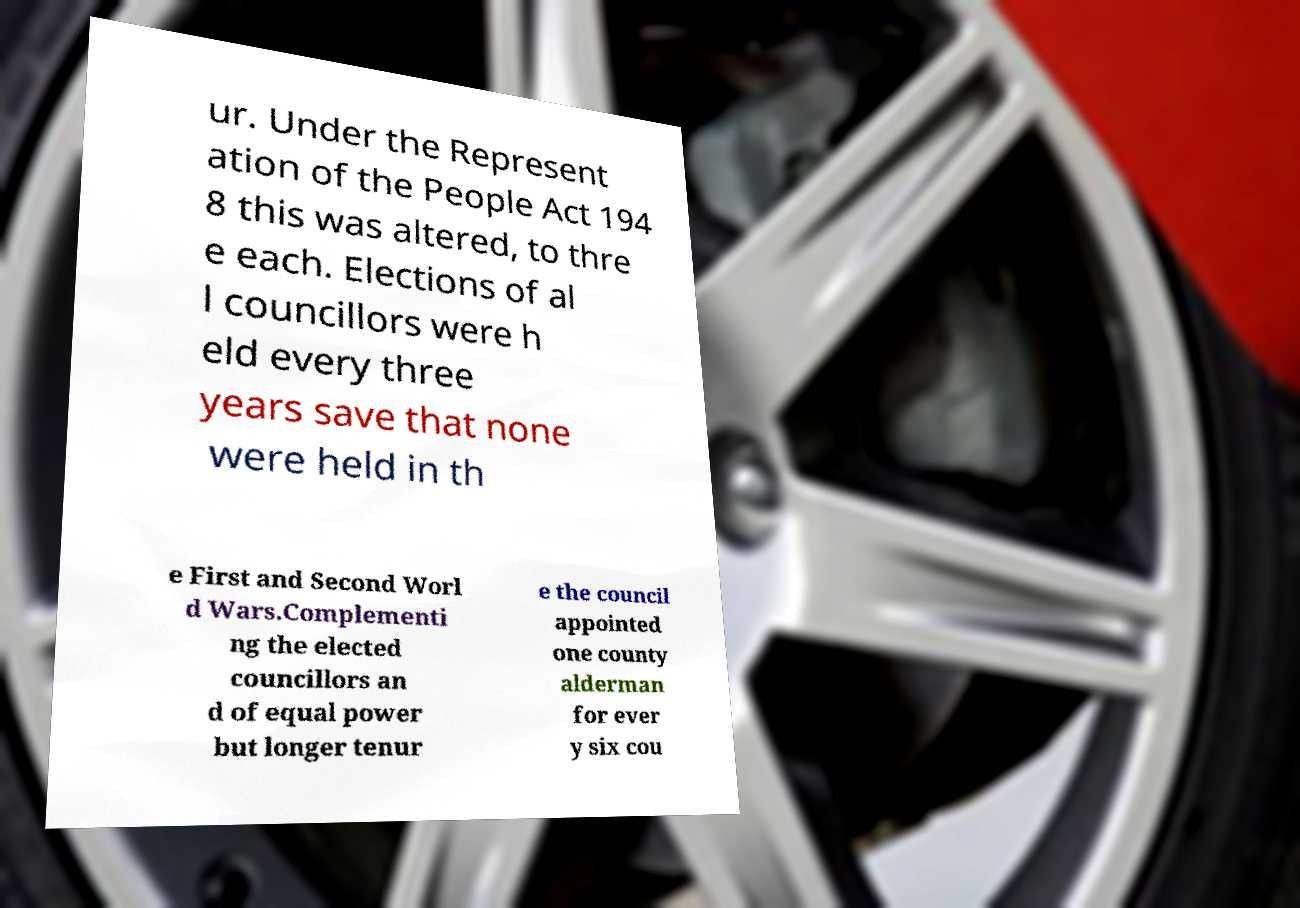I need the written content from this picture converted into text. Can you do that? ur. Under the Represent ation of the People Act 194 8 this was altered, to thre e each. Elections of al l councillors were h eld every three years save that none were held in th e First and Second Worl d Wars.Complementi ng the elected councillors an d of equal power but longer tenur e the council appointed one county alderman for ever y six cou 